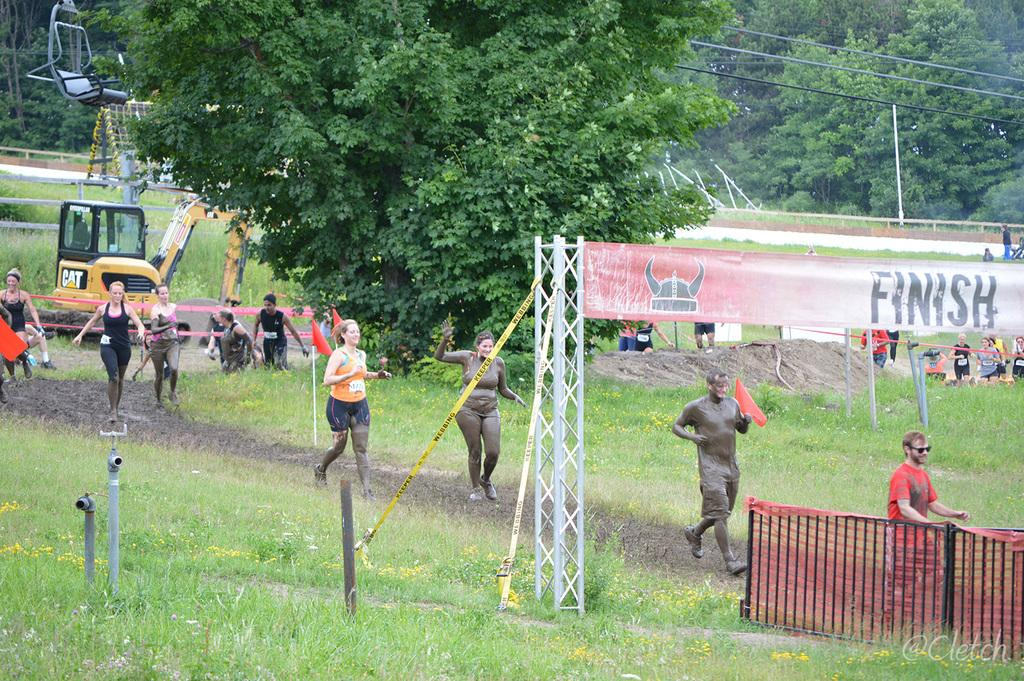<image>
Create a compact narrative representing the image presented. A group of mud covered runners approaching the finish banner in a field next to a ski lift. 